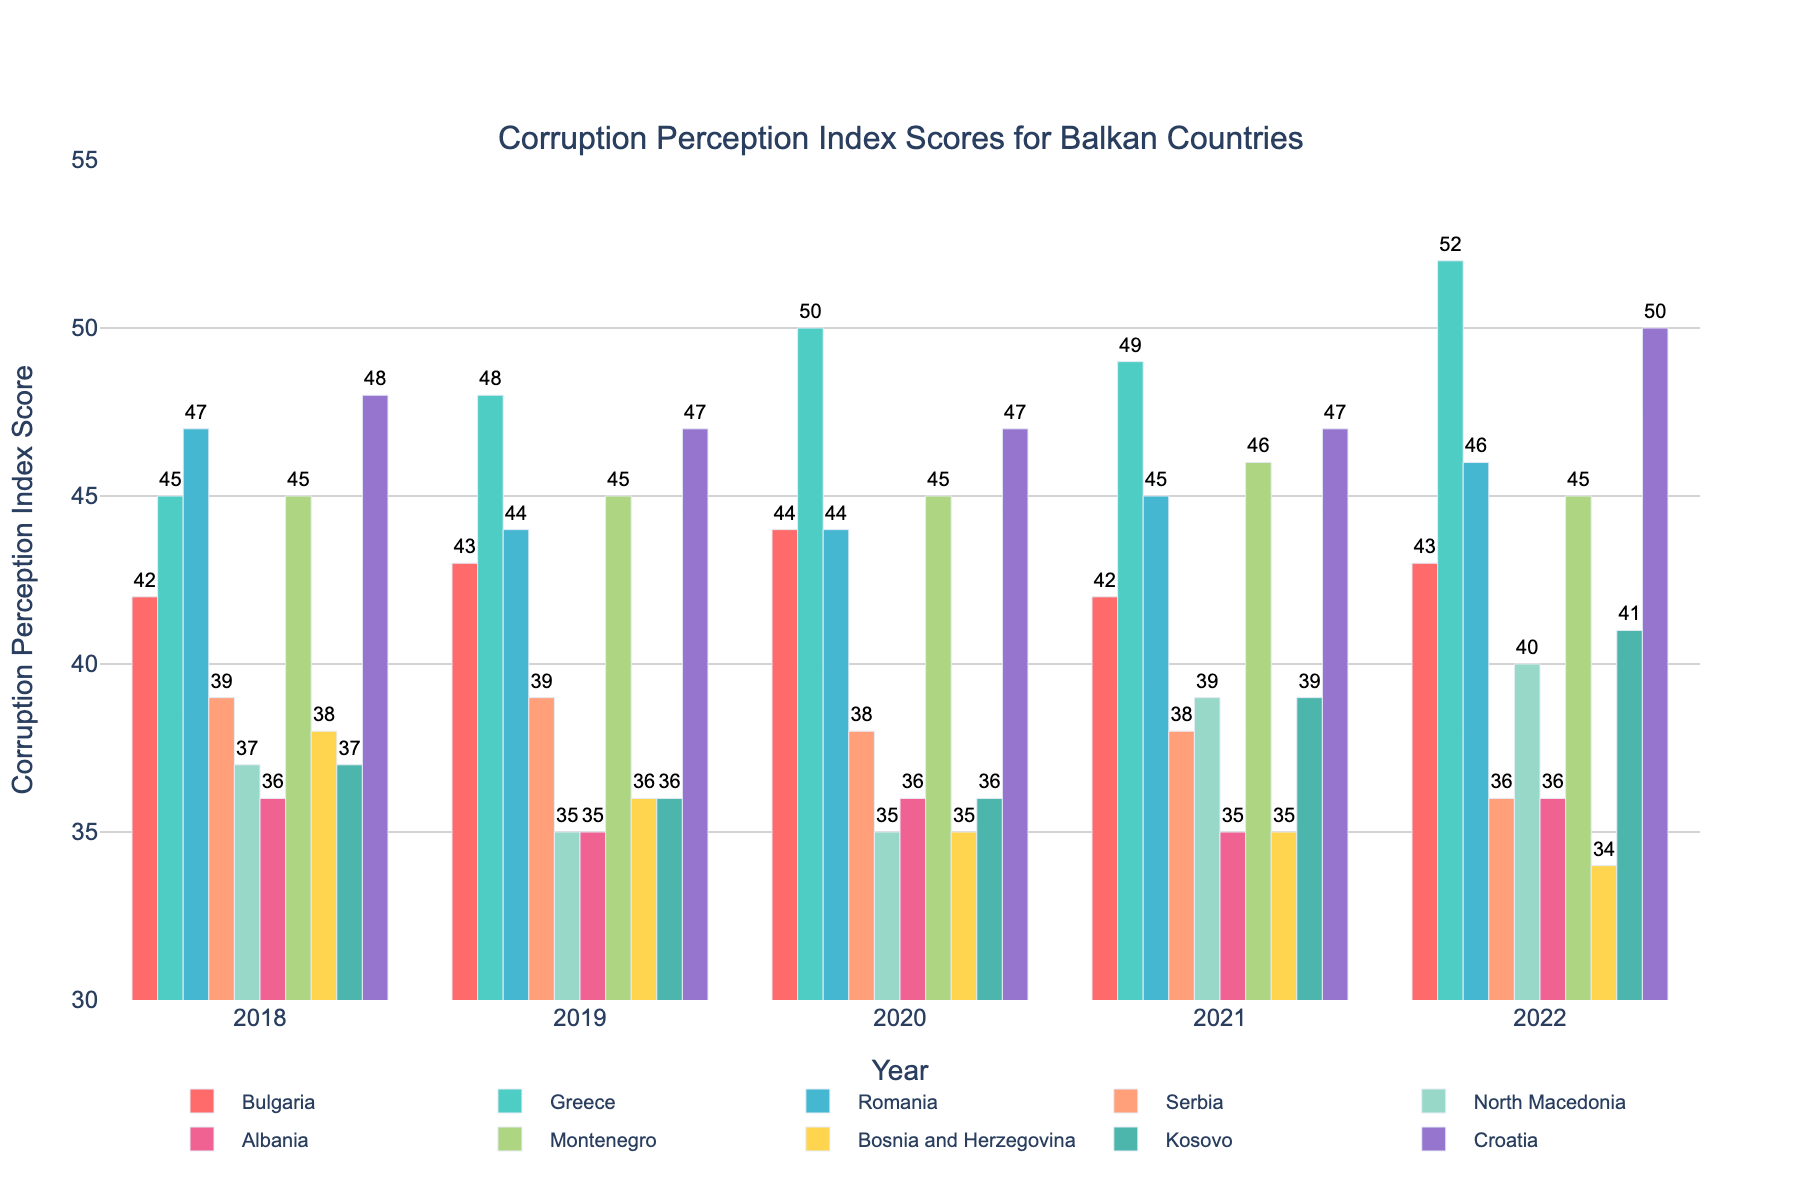What was the highest Corruption Perception Index score for Greece between 2018 and 2022? Look at the bar heights for Greece from 2018 to 2022. The highest bar represents the score in 2022, which is 52.
Answer: 52 Which country had the lowest score in 2022? Compare the heights of the bars for each country in 2022. Bosnia and Herzegovina has the lowest bar, corresponding to a score of 34.
Answer: Bosnia and Herzegovina Did any country have the same Corruption Perception Index score for three consecutive years? Check each country and see if any bars remain at the same height for three consecutive years. Montenegro had a score of 45 in 2018, 2019, and 2020.
Answer: Montenegro How did North Macedonia's score change from 2018 to 2022? Compare the height of the bars for North Macedonia in 2018 and 2022. In 2018, the bar is at 37, and in 2022, it is at 40, indicating an increase of 3 points.
Answer: Increased by 3 Which country showed the most significant improvement in its score between 2018 and 2022? Calculate the difference between the scores of each country from 2018 and 2022. The largest positive difference is for Greece, from 45 in 2018 to 52 in 2022, an increase of 7 points.
Answer: Greece How many countries had a score above 45 in 2022? Look at the bar heights for 2022 and count how many are above the 45 mark. Greece, Montenegro, and Croatia have scores above 45 in 2022.
Answer: 3 countries What is the average score of Albania over the past 5 years? Sum the scores of Albania from 2018 to 2022 and divide by 5. (36 + 35 + 36 + 35 + 36) / 5 = 35.6.
Answer: 35.6 Which two countries had equal scores in 2021? Look at the bars for 2021 and find bars that match in height. Albania and Bosnia and Herzegovina both have a score of 35 in 2021.
Answer: Albania, Bosnia and Herzegovina What is the total increase in score for Kosovo from 2018 to 2022? Subtract the score of Kosovo in 2018 (37) from its score in 2022 (41). The increase is 4 points.
Answer: 4 